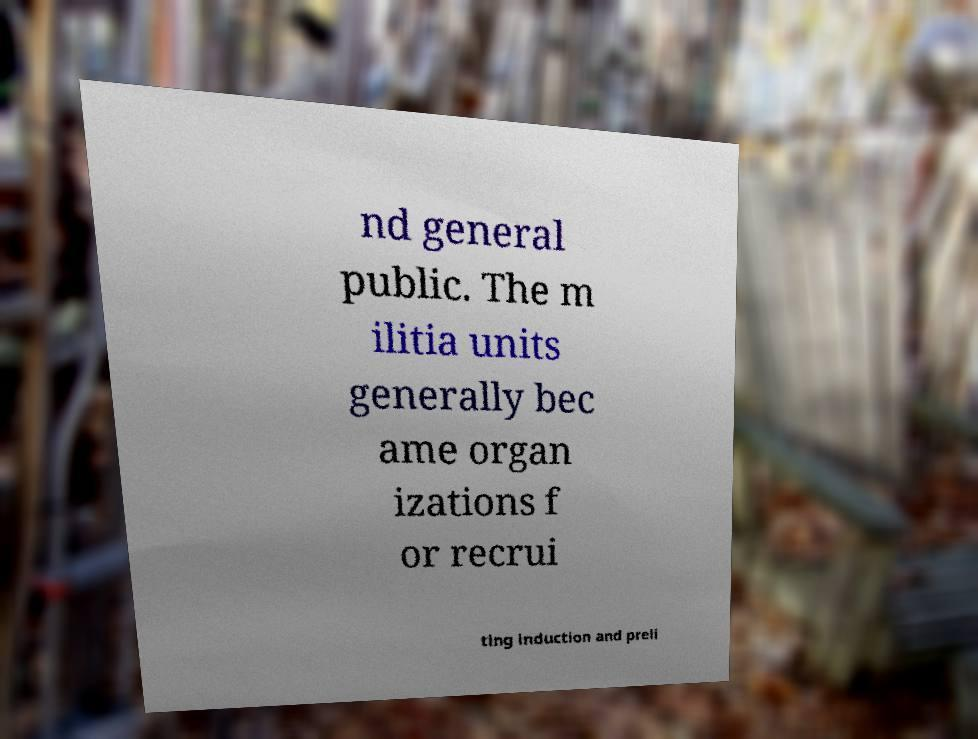What messages or text are displayed in this image? I need them in a readable, typed format. nd general public. The m ilitia units generally bec ame organ izations f or recrui ting induction and preli 